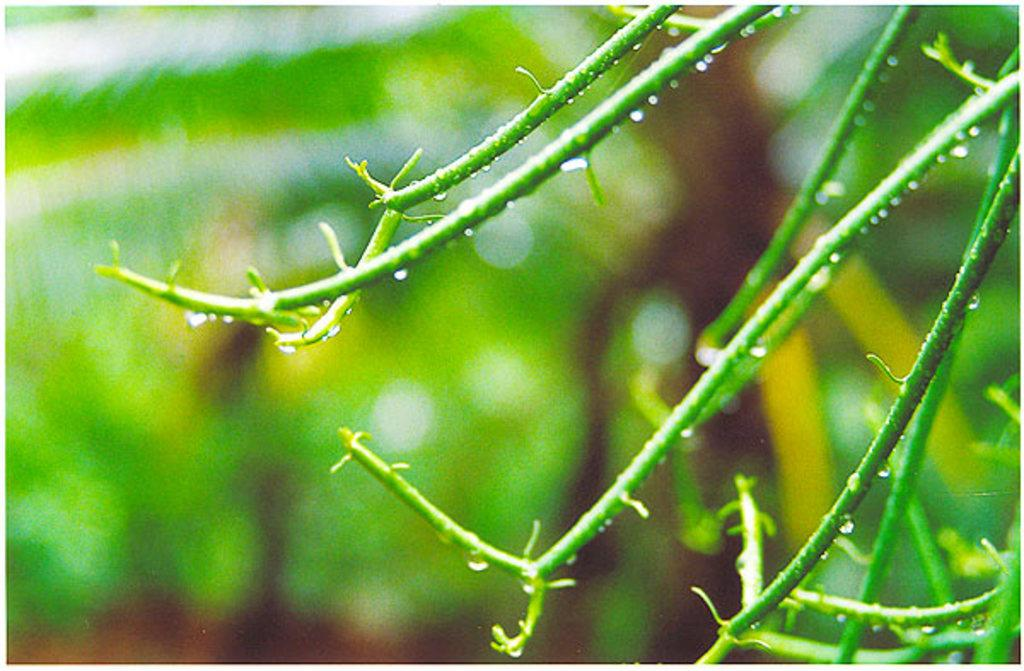What is present on the stems of the plant in the image? There are water drops on the stems of the plant in the image. What type of cable can be seen connecting the bell to the waves in the image? There is no cable, bell, or waves present in the image; it only features a plant with water drops on its stems. 